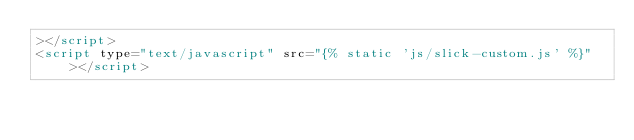<code> <loc_0><loc_0><loc_500><loc_500><_HTML_>></script>
<script type="text/javascript" src="{% static 'js/slick-custom.js' %}"></script>
</code> 